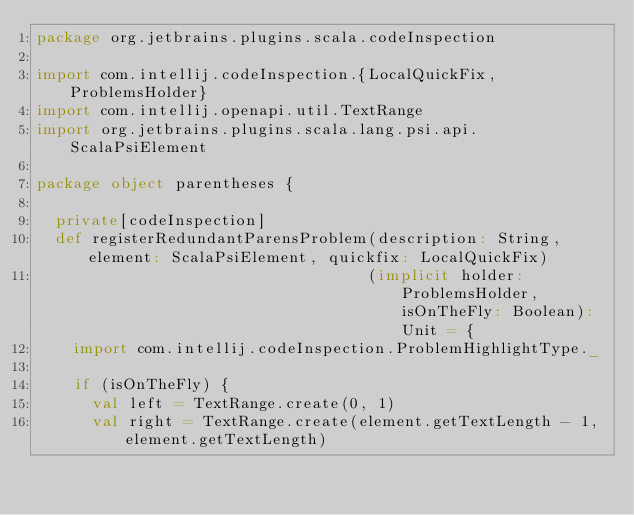Convert code to text. <code><loc_0><loc_0><loc_500><loc_500><_Scala_>package org.jetbrains.plugins.scala.codeInspection

import com.intellij.codeInspection.{LocalQuickFix, ProblemsHolder}
import com.intellij.openapi.util.TextRange
import org.jetbrains.plugins.scala.lang.psi.api.ScalaPsiElement

package object parentheses {

  private[codeInspection]
  def registerRedundantParensProblem(description: String, element: ScalaPsiElement, quickfix: LocalQuickFix)
                                    (implicit holder: ProblemsHolder, isOnTheFly: Boolean): Unit = {
    import com.intellij.codeInspection.ProblemHighlightType._

    if (isOnTheFly) {
      val left = TextRange.create(0, 1)
      val right = TextRange.create(element.getTextLength - 1, element.getTextLength)</code> 